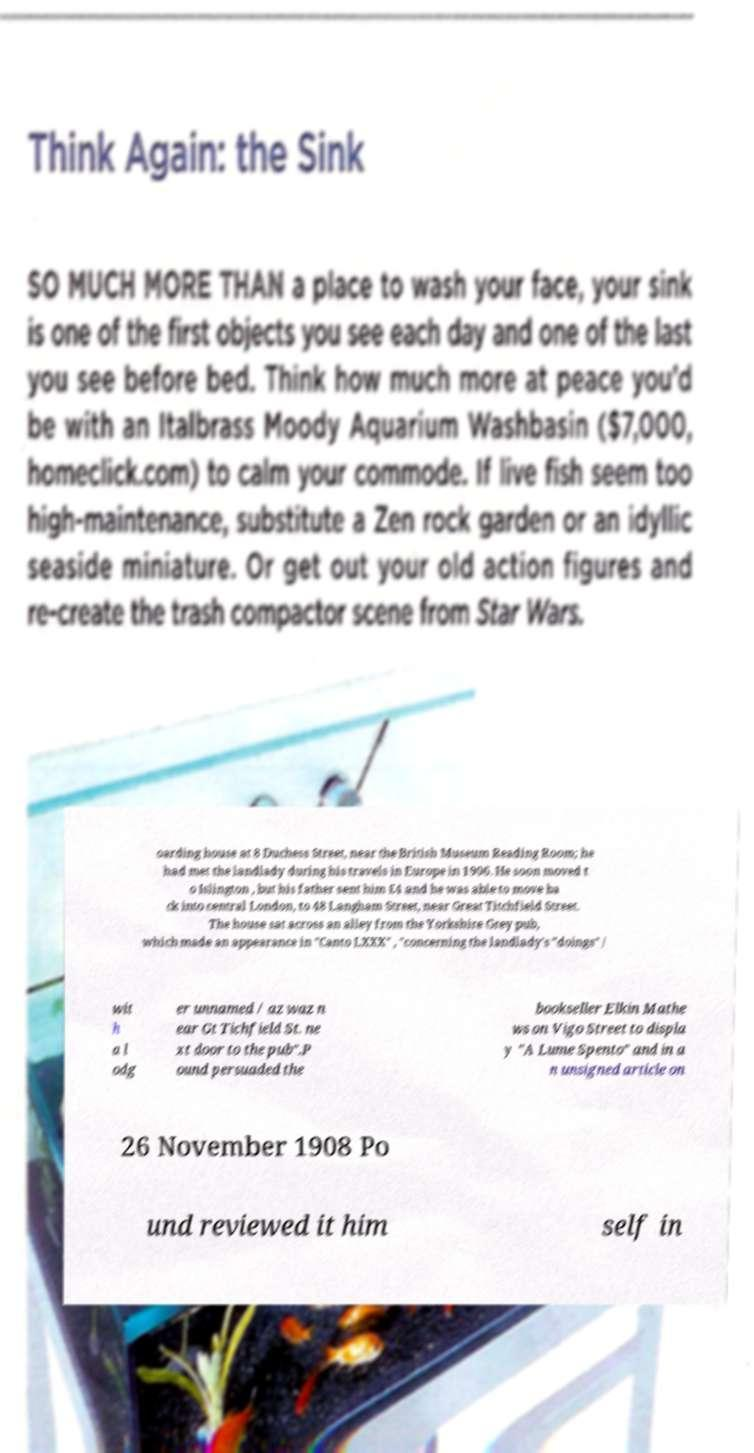Can you accurately transcribe the text from the provided image for me? oarding house at 8 Duchess Street, near the British Museum Reading Room; he had met the landlady during his travels in Europe in 1906. He soon moved t o Islington , but his father sent him £4 and he was able to move ba ck into central London, to 48 Langham Street, near Great Titchfield Street. The house sat across an alley from the Yorkshire Grey pub, which made an appearance in "Canto LXXX" , "concerning the landlady's "doings" / wit h a l odg er unnamed / az waz n ear Gt Tichfield St. ne xt door to the pub".P ound persuaded the bookseller Elkin Mathe ws on Vigo Street to displa y "A Lume Spento" and in a n unsigned article on 26 November 1908 Po und reviewed it him self in 